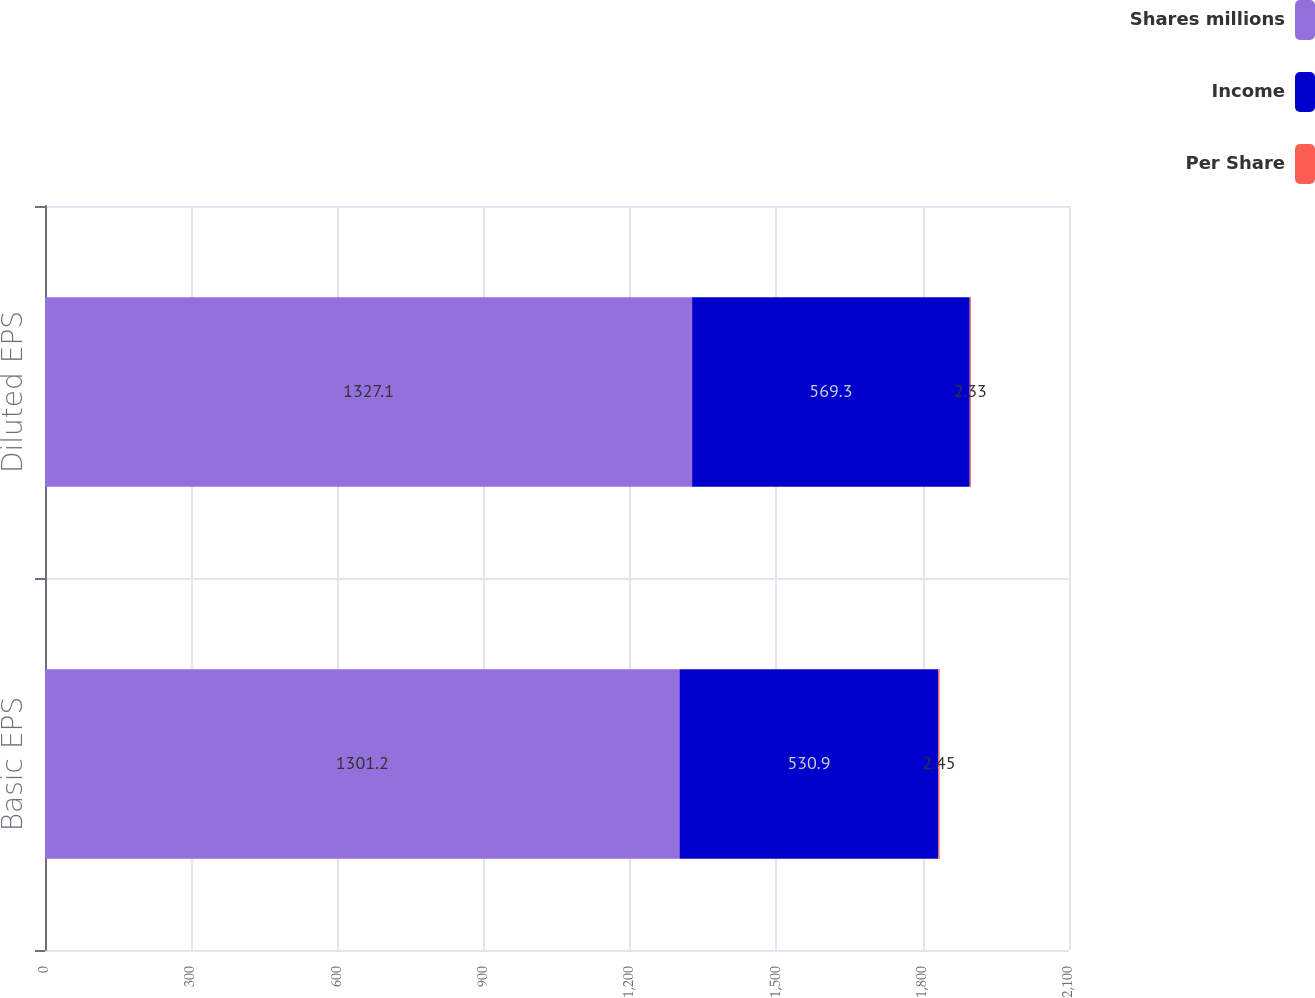Convert chart to OTSL. <chart><loc_0><loc_0><loc_500><loc_500><stacked_bar_chart><ecel><fcel>Basic EPS<fcel>Diluted EPS<nl><fcel>Shares millions<fcel>1301.2<fcel>1327.1<nl><fcel>Income<fcel>530.9<fcel>569.3<nl><fcel>Per Share<fcel>2.45<fcel>2.33<nl></chart> 